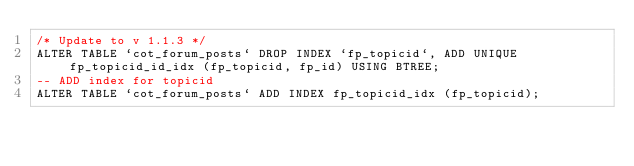Convert code to text. <code><loc_0><loc_0><loc_500><loc_500><_SQL_>/* Update to v 1.1.3 */
ALTER TABLE `cot_forum_posts` DROP INDEX `fp_topicid`, ADD UNIQUE fp_topicid_id_idx (fp_topicid, fp_id) USING BTREE;
-- ADD index for topicid
ALTER TABLE `cot_forum_posts` ADD INDEX fp_topicid_idx (fp_topicid);
</code> 